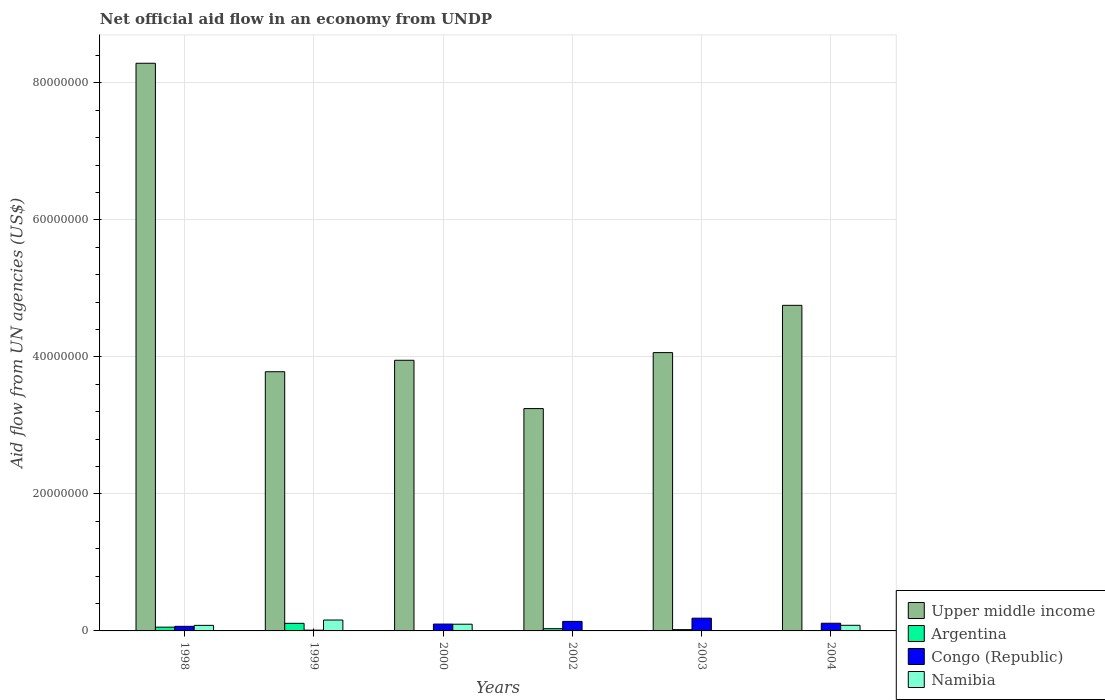Are the number of bars per tick equal to the number of legend labels?
Offer a very short reply. No. What is the net official aid flow in Namibia in 1999?
Make the answer very short. 1.59e+06. Across all years, what is the maximum net official aid flow in Congo (Republic)?
Your answer should be very brief. 1.86e+06. What is the total net official aid flow in Namibia in the graph?
Give a very brief answer. 4.26e+06. What is the difference between the net official aid flow in Upper middle income in 2002 and that in 2003?
Provide a succinct answer. -8.17e+06. What is the difference between the net official aid flow in Congo (Republic) in 2000 and the net official aid flow in Upper middle income in 2004?
Provide a succinct answer. -4.65e+07. What is the average net official aid flow in Argentina per year?
Your response must be concise. 3.63e+05. In the year 1999, what is the difference between the net official aid flow in Upper middle income and net official aid flow in Namibia?
Provide a short and direct response. 3.62e+07. What is the ratio of the net official aid flow in Argentina in 1999 to that in 2003?
Give a very brief answer. 5.84. What is the difference between the highest and the lowest net official aid flow in Namibia?
Offer a very short reply. 1.59e+06. Is the sum of the net official aid flow in Upper middle income in 1999 and 2004 greater than the maximum net official aid flow in Namibia across all years?
Keep it short and to the point. Yes. Is it the case that in every year, the sum of the net official aid flow in Upper middle income and net official aid flow in Argentina is greater than the net official aid flow in Namibia?
Ensure brevity in your answer.  Yes. How many bars are there?
Provide a succinct answer. 21. Are the values on the major ticks of Y-axis written in scientific E-notation?
Provide a short and direct response. No. Does the graph contain any zero values?
Give a very brief answer. Yes. How many legend labels are there?
Your answer should be very brief. 4. What is the title of the graph?
Your response must be concise. Net official aid flow in an economy from UNDP. Does "Jordan" appear as one of the legend labels in the graph?
Offer a terse response. No. What is the label or title of the Y-axis?
Provide a short and direct response. Aid flow from UN agencies (US$). What is the Aid flow from UN agencies (US$) of Upper middle income in 1998?
Make the answer very short. 8.28e+07. What is the Aid flow from UN agencies (US$) of Congo (Republic) in 1998?
Provide a succinct answer. 6.70e+05. What is the Aid flow from UN agencies (US$) in Namibia in 1998?
Your answer should be very brief. 8.10e+05. What is the Aid flow from UN agencies (US$) of Upper middle income in 1999?
Ensure brevity in your answer.  3.78e+07. What is the Aid flow from UN agencies (US$) in Argentina in 1999?
Your answer should be very brief. 1.11e+06. What is the Aid flow from UN agencies (US$) of Congo (Republic) in 1999?
Keep it short and to the point. 1.10e+05. What is the Aid flow from UN agencies (US$) in Namibia in 1999?
Make the answer very short. 1.59e+06. What is the Aid flow from UN agencies (US$) in Upper middle income in 2000?
Make the answer very short. 3.95e+07. What is the Aid flow from UN agencies (US$) of Argentina in 2000?
Provide a succinct answer. 0. What is the Aid flow from UN agencies (US$) of Namibia in 2000?
Offer a very short reply. 9.80e+05. What is the Aid flow from UN agencies (US$) in Upper middle income in 2002?
Ensure brevity in your answer.  3.24e+07. What is the Aid flow from UN agencies (US$) of Argentina in 2002?
Your answer should be compact. 3.30e+05. What is the Aid flow from UN agencies (US$) in Congo (Republic) in 2002?
Provide a succinct answer. 1.39e+06. What is the Aid flow from UN agencies (US$) in Namibia in 2002?
Provide a short and direct response. 0. What is the Aid flow from UN agencies (US$) in Upper middle income in 2003?
Keep it short and to the point. 4.06e+07. What is the Aid flow from UN agencies (US$) in Argentina in 2003?
Your answer should be very brief. 1.90e+05. What is the Aid flow from UN agencies (US$) of Congo (Republic) in 2003?
Offer a very short reply. 1.86e+06. What is the Aid flow from UN agencies (US$) of Namibia in 2003?
Give a very brief answer. 6.00e+04. What is the Aid flow from UN agencies (US$) in Upper middle income in 2004?
Make the answer very short. 4.75e+07. What is the Aid flow from UN agencies (US$) of Argentina in 2004?
Give a very brief answer. 0. What is the Aid flow from UN agencies (US$) of Congo (Republic) in 2004?
Make the answer very short. 1.12e+06. What is the Aid flow from UN agencies (US$) in Namibia in 2004?
Provide a short and direct response. 8.20e+05. Across all years, what is the maximum Aid flow from UN agencies (US$) of Upper middle income?
Your answer should be compact. 8.28e+07. Across all years, what is the maximum Aid flow from UN agencies (US$) of Argentina?
Offer a very short reply. 1.11e+06. Across all years, what is the maximum Aid flow from UN agencies (US$) in Congo (Republic)?
Offer a terse response. 1.86e+06. Across all years, what is the maximum Aid flow from UN agencies (US$) in Namibia?
Provide a short and direct response. 1.59e+06. Across all years, what is the minimum Aid flow from UN agencies (US$) of Upper middle income?
Your answer should be very brief. 3.24e+07. Across all years, what is the minimum Aid flow from UN agencies (US$) of Argentina?
Ensure brevity in your answer.  0. Across all years, what is the minimum Aid flow from UN agencies (US$) of Congo (Republic)?
Your answer should be very brief. 1.10e+05. Across all years, what is the minimum Aid flow from UN agencies (US$) in Namibia?
Offer a terse response. 0. What is the total Aid flow from UN agencies (US$) of Upper middle income in the graph?
Your response must be concise. 2.81e+08. What is the total Aid flow from UN agencies (US$) in Argentina in the graph?
Keep it short and to the point. 2.18e+06. What is the total Aid flow from UN agencies (US$) of Congo (Republic) in the graph?
Your response must be concise. 6.15e+06. What is the total Aid flow from UN agencies (US$) in Namibia in the graph?
Provide a succinct answer. 4.26e+06. What is the difference between the Aid flow from UN agencies (US$) in Upper middle income in 1998 and that in 1999?
Your answer should be compact. 4.50e+07. What is the difference between the Aid flow from UN agencies (US$) of Argentina in 1998 and that in 1999?
Offer a terse response. -5.60e+05. What is the difference between the Aid flow from UN agencies (US$) in Congo (Republic) in 1998 and that in 1999?
Give a very brief answer. 5.60e+05. What is the difference between the Aid flow from UN agencies (US$) in Namibia in 1998 and that in 1999?
Make the answer very short. -7.80e+05. What is the difference between the Aid flow from UN agencies (US$) in Upper middle income in 1998 and that in 2000?
Offer a very short reply. 4.34e+07. What is the difference between the Aid flow from UN agencies (US$) in Congo (Republic) in 1998 and that in 2000?
Give a very brief answer. -3.30e+05. What is the difference between the Aid flow from UN agencies (US$) of Namibia in 1998 and that in 2000?
Your answer should be very brief. -1.70e+05. What is the difference between the Aid flow from UN agencies (US$) in Upper middle income in 1998 and that in 2002?
Provide a succinct answer. 5.04e+07. What is the difference between the Aid flow from UN agencies (US$) in Congo (Republic) in 1998 and that in 2002?
Provide a short and direct response. -7.20e+05. What is the difference between the Aid flow from UN agencies (US$) in Upper middle income in 1998 and that in 2003?
Your answer should be compact. 4.22e+07. What is the difference between the Aid flow from UN agencies (US$) of Argentina in 1998 and that in 2003?
Ensure brevity in your answer.  3.60e+05. What is the difference between the Aid flow from UN agencies (US$) in Congo (Republic) in 1998 and that in 2003?
Provide a succinct answer. -1.19e+06. What is the difference between the Aid flow from UN agencies (US$) in Namibia in 1998 and that in 2003?
Provide a succinct answer. 7.50e+05. What is the difference between the Aid flow from UN agencies (US$) in Upper middle income in 1998 and that in 2004?
Your answer should be compact. 3.53e+07. What is the difference between the Aid flow from UN agencies (US$) in Congo (Republic) in 1998 and that in 2004?
Your answer should be very brief. -4.50e+05. What is the difference between the Aid flow from UN agencies (US$) in Upper middle income in 1999 and that in 2000?
Provide a succinct answer. -1.67e+06. What is the difference between the Aid flow from UN agencies (US$) of Congo (Republic) in 1999 and that in 2000?
Give a very brief answer. -8.90e+05. What is the difference between the Aid flow from UN agencies (US$) in Namibia in 1999 and that in 2000?
Make the answer very short. 6.10e+05. What is the difference between the Aid flow from UN agencies (US$) of Upper middle income in 1999 and that in 2002?
Your answer should be compact. 5.38e+06. What is the difference between the Aid flow from UN agencies (US$) in Argentina in 1999 and that in 2002?
Your answer should be compact. 7.80e+05. What is the difference between the Aid flow from UN agencies (US$) in Congo (Republic) in 1999 and that in 2002?
Offer a very short reply. -1.28e+06. What is the difference between the Aid flow from UN agencies (US$) in Upper middle income in 1999 and that in 2003?
Give a very brief answer. -2.79e+06. What is the difference between the Aid flow from UN agencies (US$) of Argentina in 1999 and that in 2003?
Make the answer very short. 9.20e+05. What is the difference between the Aid flow from UN agencies (US$) in Congo (Republic) in 1999 and that in 2003?
Offer a very short reply. -1.75e+06. What is the difference between the Aid flow from UN agencies (US$) in Namibia in 1999 and that in 2003?
Keep it short and to the point. 1.53e+06. What is the difference between the Aid flow from UN agencies (US$) of Upper middle income in 1999 and that in 2004?
Offer a very short reply. -9.69e+06. What is the difference between the Aid flow from UN agencies (US$) in Congo (Republic) in 1999 and that in 2004?
Give a very brief answer. -1.01e+06. What is the difference between the Aid flow from UN agencies (US$) of Namibia in 1999 and that in 2004?
Ensure brevity in your answer.  7.70e+05. What is the difference between the Aid flow from UN agencies (US$) in Upper middle income in 2000 and that in 2002?
Make the answer very short. 7.05e+06. What is the difference between the Aid flow from UN agencies (US$) in Congo (Republic) in 2000 and that in 2002?
Provide a succinct answer. -3.90e+05. What is the difference between the Aid flow from UN agencies (US$) of Upper middle income in 2000 and that in 2003?
Keep it short and to the point. -1.12e+06. What is the difference between the Aid flow from UN agencies (US$) in Congo (Republic) in 2000 and that in 2003?
Offer a very short reply. -8.60e+05. What is the difference between the Aid flow from UN agencies (US$) in Namibia in 2000 and that in 2003?
Offer a very short reply. 9.20e+05. What is the difference between the Aid flow from UN agencies (US$) in Upper middle income in 2000 and that in 2004?
Your answer should be very brief. -8.02e+06. What is the difference between the Aid flow from UN agencies (US$) of Upper middle income in 2002 and that in 2003?
Your answer should be compact. -8.17e+06. What is the difference between the Aid flow from UN agencies (US$) of Argentina in 2002 and that in 2003?
Provide a succinct answer. 1.40e+05. What is the difference between the Aid flow from UN agencies (US$) in Congo (Republic) in 2002 and that in 2003?
Ensure brevity in your answer.  -4.70e+05. What is the difference between the Aid flow from UN agencies (US$) in Upper middle income in 2002 and that in 2004?
Your answer should be very brief. -1.51e+07. What is the difference between the Aid flow from UN agencies (US$) in Upper middle income in 2003 and that in 2004?
Your response must be concise. -6.90e+06. What is the difference between the Aid flow from UN agencies (US$) in Congo (Republic) in 2003 and that in 2004?
Your response must be concise. 7.40e+05. What is the difference between the Aid flow from UN agencies (US$) of Namibia in 2003 and that in 2004?
Offer a terse response. -7.60e+05. What is the difference between the Aid flow from UN agencies (US$) in Upper middle income in 1998 and the Aid flow from UN agencies (US$) in Argentina in 1999?
Make the answer very short. 8.17e+07. What is the difference between the Aid flow from UN agencies (US$) in Upper middle income in 1998 and the Aid flow from UN agencies (US$) in Congo (Republic) in 1999?
Your response must be concise. 8.27e+07. What is the difference between the Aid flow from UN agencies (US$) in Upper middle income in 1998 and the Aid flow from UN agencies (US$) in Namibia in 1999?
Ensure brevity in your answer.  8.13e+07. What is the difference between the Aid flow from UN agencies (US$) in Argentina in 1998 and the Aid flow from UN agencies (US$) in Namibia in 1999?
Ensure brevity in your answer.  -1.04e+06. What is the difference between the Aid flow from UN agencies (US$) of Congo (Republic) in 1998 and the Aid flow from UN agencies (US$) of Namibia in 1999?
Your answer should be compact. -9.20e+05. What is the difference between the Aid flow from UN agencies (US$) in Upper middle income in 1998 and the Aid flow from UN agencies (US$) in Congo (Republic) in 2000?
Provide a short and direct response. 8.18e+07. What is the difference between the Aid flow from UN agencies (US$) in Upper middle income in 1998 and the Aid flow from UN agencies (US$) in Namibia in 2000?
Make the answer very short. 8.19e+07. What is the difference between the Aid flow from UN agencies (US$) in Argentina in 1998 and the Aid flow from UN agencies (US$) in Congo (Republic) in 2000?
Your answer should be compact. -4.50e+05. What is the difference between the Aid flow from UN agencies (US$) of Argentina in 1998 and the Aid flow from UN agencies (US$) of Namibia in 2000?
Provide a short and direct response. -4.30e+05. What is the difference between the Aid flow from UN agencies (US$) of Congo (Republic) in 1998 and the Aid flow from UN agencies (US$) of Namibia in 2000?
Make the answer very short. -3.10e+05. What is the difference between the Aid flow from UN agencies (US$) in Upper middle income in 1998 and the Aid flow from UN agencies (US$) in Argentina in 2002?
Make the answer very short. 8.25e+07. What is the difference between the Aid flow from UN agencies (US$) of Upper middle income in 1998 and the Aid flow from UN agencies (US$) of Congo (Republic) in 2002?
Provide a short and direct response. 8.15e+07. What is the difference between the Aid flow from UN agencies (US$) in Argentina in 1998 and the Aid flow from UN agencies (US$) in Congo (Republic) in 2002?
Provide a short and direct response. -8.40e+05. What is the difference between the Aid flow from UN agencies (US$) in Upper middle income in 1998 and the Aid flow from UN agencies (US$) in Argentina in 2003?
Make the answer very short. 8.27e+07. What is the difference between the Aid flow from UN agencies (US$) of Upper middle income in 1998 and the Aid flow from UN agencies (US$) of Congo (Republic) in 2003?
Offer a terse response. 8.10e+07. What is the difference between the Aid flow from UN agencies (US$) of Upper middle income in 1998 and the Aid flow from UN agencies (US$) of Namibia in 2003?
Offer a very short reply. 8.28e+07. What is the difference between the Aid flow from UN agencies (US$) in Argentina in 1998 and the Aid flow from UN agencies (US$) in Congo (Republic) in 2003?
Offer a very short reply. -1.31e+06. What is the difference between the Aid flow from UN agencies (US$) in Argentina in 1998 and the Aid flow from UN agencies (US$) in Namibia in 2003?
Your answer should be very brief. 4.90e+05. What is the difference between the Aid flow from UN agencies (US$) in Upper middle income in 1998 and the Aid flow from UN agencies (US$) in Congo (Republic) in 2004?
Your answer should be compact. 8.17e+07. What is the difference between the Aid flow from UN agencies (US$) in Upper middle income in 1998 and the Aid flow from UN agencies (US$) in Namibia in 2004?
Your response must be concise. 8.20e+07. What is the difference between the Aid flow from UN agencies (US$) in Argentina in 1998 and the Aid flow from UN agencies (US$) in Congo (Republic) in 2004?
Your answer should be very brief. -5.70e+05. What is the difference between the Aid flow from UN agencies (US$) of Congo (Republic) in 1998 and the Aid flow from UN agencies (US$) of Namibia in 2004?
Your answer should be very brief. -1.50e+05. What is the difference between the Aid flow from UN agencies (US$) in Upper middle income in 1999 and the Aid flow from UN agencies (US$) in Congo (Republic) in 2000?
Your answer should be compact. 3.68e+07. What is the difference between the Aid flow from UN agencies (US$) in Upper middle income in 1999 and the Aid flow from UN agencies (US$) in Namibia in 2000?
Make the answer very short. 3.68e+07. What is the difference between the Aid flow from UN agencies (US$) of Argentina in 1999 and the Aid flow from UN agencies (US$) of Congo (Republic) in 2000?
Offer a very short reply. 1.10e+05. What is the difference between the Aid flow from UN agencies (US$) of Argentina in 1999 and the Aid flow from UN agencies (US$) of Namibia in 2000?
Provide a succinct answer. 1.30e+05. What is the difference between the Aid flow from UN agencies (US$) of Congo (Republic) in 1999 and the Aid flow from UN agencies (US$) of Namibia in 2000?
Your response must be concise. -8.70e+05. What is the difference between the Aid flow from UN agencies (US$) of Upper middle income in 1999 and the Aid flow from UN agencies (US$) of Argentina in 2002?
Your response must be concise. 3.75e+07. What is the difference between the Aid flow from UN agencies (US$) of Upper middle income in 1999 and the Aid flow from UN agencies (US$) of Congo (Republic) in 2002?
Make the answer very short. 3.64e+07. What is the difference between the Aid flow from UN agencies (US$) of Argentina in 1999 and the Aid flow from UN agencies (US$) of Congo (Republic) in 2002?
Offer a terse response. -2.80e+05. What is the difference between the Aid flow from UN agencies (US$) of Upper middle income in 1999 and the Aid flow from UN agencies (US$) of Argentina in 2003?
Ensure brevity in your answer.  3.76e+07. What is the difference between the Aid flow from UN agencies (US$) of Upper middle income in 1999 and the Aid flow from UN agencies (US$) of Congo (Republic) in 2003?
Make the answer very short. 3.60e+07. What is the difference between the Aid flow from UN agencies (US$) of Upper middle income in 1999 and the Aid flow from UN agencies (US$) of Namibia in 2003?
Ensure brevity in your answer.  3.78e+07. What is the difference between the Aid flow from UN agencies (US$) of Argentina in 1999 and the Aid flow from UN agencies (US$) of Congo (Republic) in 2003?
Provide a short and direct response. -7.50e+05. What is the difference between the Aid flow from UN agencies (US$) in Argentina in 1999 and the Aid flow from UN agencies (US$) in Namibia in 2003?
Offer a very short reply. 1.05e+06. What is the difference between the Aid flow from UN agencies (US$) of Upper middle income in 1999 and the Aid flow from UN agencies (US$) of Congo (Republic) in 2004?
Offer a terse response. 3.67e+07. What is the difference between the Aid flow from UN agencies (US$) of Upper middle income in 1999 and the Aid flow from UN agencies (US$) of Namibia in 2004?
Keep it short and to the point. 3.70e+07. What is the difference between the Aid flow from UN agencies (US$) of Argentina in 1999 and the Aid flow from UN agencies (US$) of Congo (Republic) in 2004?
Give a very brief answer. -10000. What is the difference between the Aid flow from UN agencies (US$) in Congo (Republic) in 1999 and the Aid flow from UN agencies (US$) in Namibia in 2004?
Keep it short and to the point. -7.10e+05. What is the difference between the Aid flow from UN agencies (US$) of Upper middle income in 2000 and the Aid flow from UN agencies (US$) of Argentina in 2002?
Ensure brevity in your answer.  3.92e+07. What is the difference between the Aid flow from UN agencies (US$) of Upper middle income in 2000 and the Aid flow from UN agencies (US$) of Congo (Republic) in 2002?
Give a very brief answer. 3.81e+07. What is the difference between the Aid flow from UN agencies (US$) in Upper middle income in 2000 and the Aid flow from UN agencies (US$) in Argentina in 2003?
Offer a terse response. 3.93e+07. What is the difference between the Aid flow from UN agencies (US$) of Upper middle income in 2000 and the Aid flow from UN agencies (US$) of Congo (Republic) in 2003?
Offer a terse response. 3.76e+07. What is the difference between the Aid flow from UN agencies (US$) in Upper middle income in 2000 and the Aid flow from UN agencies (US$) in Namibia in 2003?
Give a very brief answer. 3.94e+07. What is the difference between the Aid flow from UN agencies (US$) in Congo (Republic) in 2000 and the Aid flow from UN agencies (US$) in Namibia in 2003?
Your answer should be compact. 9.40e+05. What is the difference between the Aid flow from UN agencies (US$) in Upper middle income in 2000 and the Aid flow from UN agencies (US$) in Congo (Republic) in 2004?
Provide a short and direct response. 3.84e+07. What is the difference between the Aid flow from UN agencies (US$) in Upper middle income in 2000 and the Aid flow from UN agencies (US$) in Namibia in 2004?
Offer a terse response. 3.87e+07. What is the difference between the Aid flow from UN agencies (US$) of Congo (Republic) in 2000 and the Aid flow from UN agencies (US$) of Namibia in 2004?
Your response must be concise. 1.80e+05. What is the difference between the Aid flow from UN agencies (US$) in Upper middle income in 2002 and the Aid flow from UN agencies (US$) in Argentina in 2003?
Offer a terse response. 3.23e+07. What is the difference between the Aid flow from UN agencies (US$) in Upper middle income in 2002 and the Aid flow from UN agencies (US$) in Congo (Republic) in 2003?
Your answer should be compact. 3.06e+07. What is the difference between the Aid flow from UN agencies (US$) of Upper middle income in 2002 and the Aid flow from UN agencies (US$) of Namibia in 2003?
Provide a succinct answer. 3.24e+07. What is the difference between the Aid flow from UN agencies (US$) in Argentina in 2002 and the Aid flow from UN agencies (US$) in Congo (Republic) in 2003?
Give a very brief answer. -1.53e+06. What is the difference between the Aid flow from UN agencies (US$) of Congo (Republic) in 2002 and the Aid flow from UN agencies (US$) of Namibia in 2003?
Make the answer very short. 1.33e+06. What is the difference between the Aid flow from UN agencies (US$) in Upper middle income in 2002 and the Aid flow from UN agencies (US$) in Congo (Republic) in 2004?
Ensure brevity in your answer.  3.13e+07. What is the difference between the Aid flow from UN agencies (US$) of Upper middle income in 2002 and the Aid flow from UN agencies (US$) of Namibia in 2004?
Make the answer very short. 3.16e+07. What is the difference between the Aid flow from UN agencies (US$) of Argentina in 2002 and the Aid flow from UN agencies (US$) of Congo (Republic) in 2004?
Your answer should be very brief. -7.90e+05. What is the difference between the Aid flow from UN agencies (US$) of Argentina in 2002 and the Aid flow from UN agencies (US$) of Namibia in 2004?
Offer a very short reply. -4.90e+05. What is the difference between the Aid flow from UN agencies (US$) of Congo (Republic) in 2002 and the Aid flow from UN agencies (US$) of Namibia in 2004?
Your answer should be compact. 5.70e+05. What is the difference between the Aid flow from UN agencies (US$) in Upper middle income in 2003 and the Aid flow from UN agencies (US$) in Congo (Republic) in 2004?
Your answer should be very brief. 3.95e+07. What is the difference between the Aid flow from UN agencies (US$) in Upper middle income in 2003 and the Aid flow from UN agencies (US$) in Namibia in 2004?
Provide a succinct answer. 3.98e+07. What is the difference between the Aid flow from UN agencies (US$) of Argentina in 2003 and the Aid flow from UN agencies (US$) of Congo (Republic) in 2004?
Your response must be concise. -9.30e+05. What is the difference between the Aid flow from UN agencies (US$) of Argentina in 2003 and the Aid flow from UN agencies (US$) of Namibia in 2004?
Provide a short and direct response. -6.30e+05. What is the difference between the Aid flow from UN agencies (US$) of Congo (Republic) in 2003 and the Aid flow from UN agencies (US$) of Namibia in 2004?
Ensure brevity in your answer.  1.04e+06. What is the average Aid flow from UN agencies (US$) in Upper middle income per year?
Provide a short and direct response. 4.68e+07. What is the average Aid flow from UN agencies (US$) in Argentina per year?
Ensure brevity in your answer.  3.63e+05. What is the average Aid flow from UN agencies (US$) of Congo (Republic) per year?
Ensure brevity in your answer.  1.02e+06. What is the average Aid flow from UN agencies (US$) of Namibia per year?
Provide a short and direct response. 7.10e+05. In the year 1998, what is the difference between the Aid flow from UN agencies (US$) of Upper middle income and Aid flow from UN agencies (US$) of Argentina?
Offer a very short reply. 8.23e+07. In the year 1998, what is the difference between the Aid flow from UN agencies (US$) of Upper middle income and Aid flow from UN agencies (US$) of Congo (Republic)?
Ensure brevity in your answer.  8.22e+07. In the year 1998, what is the difference between the Aid flow from UN agencies (US$) of Upper middle income and Aid flow from UN agencies (US$) of Namibia?
Give a very brief answer. 8.20e+07. In the year 1998, what is the difference between the Aid flow from UN agencies (US$) of Argentina and Aid flow from UN agencies (US$) of Congo (Republic)?
Offer a very short reply. -1.20e+05. In the year 1998, what is the difference between the Aid flow from UN agencies (US$) in Argentina and Aid flow from UN agencies (US$) in Namibia?
Your answer should be very brief. -2.60e+05. In the year 1999, what is the difference between the Aid flow from UN agencies (US$) of Upper middle income and Aid flow from UN agencies (US$) of Argentina?
Provide a succinct answer. 3.67e+07. In the year 1999, what is the difference between the Aid flow from UN agencies (US$) of Upper middle income and Aid flow from UN agencies (US$) of Congo (Republic)?
Ensure brevity in your answer.  3.77e+07. In the year 1999, what is the difference between the Aid flow from UN agencies (US$) of Upper middle income and Aid flow from UN agencies (US$) of Namibia?
Make the answer very short. 3.62e+07. In the year 1999, what is the difference between the Aid flow from UN agencies (US$) of Argentina and Aid flow from UN agencies (US$) of Congo (Republic)?
Provide a succinct answer. 1.00e+06. In the year 1999, what is the difference between the Aid flow from UN agencies (US$) in Argentina and Aid flow from UN agencies (US$) in Namibia?
Offer a very short reply. -4.80e+05. In the year 1999, what is the difference between the Aid flow from UN agencies (US$) in Congo (Republic) and Aid flow from UN agencies (US$) in Namibia?
Your answer should be compact. -1.48e+06. In the year 2000, what is the difference between the Aid flow from UN agencies (US$) of Upper middle income and Aid flow from UN agencies (US$) of Congo (Republic)?
Give a very brief answer. 3.85e+07. In the year 2000, what is the difference between the Aid flow from UN agencies (US$) in Upper middle income and Aid flow from UN agencies (US$) in Namibia?
Provide a succinct answer. 3.85e+07. In the year 2000, what is the difference between the Aid flow from UN agencies (US$) in Congo (Republic) and Aid flow from UN agencies (US$) in Namibia?
Ensure brevity in your answer.  2.00e+04. In the year 2002, what is the difference between the Aid flow from UN agencies (US$) of Upper middle income and Aid flow from UN agencies (US$) of Argentina?
Provide a succinct answer. 3.21e+07. In the year 2002, what is the difference between the Aid flow from UN agencies (US$) of Upper middle income and Aid flow from UN agencies (US$) of Congo (Republic)?
Ensure brevity in your answer.  3.11e+07. In the year 2002, what is the difference between the Aid flow from UN agencies (US$) in Argentina and Aid flow from UN agencies (US$) in Congo (Republic)?
Make the answer very short. -1.06e+06. In the year 2003, what is the difference between the Aid flow from UN agencies (US$) in Upper middle income and Aid flow from UN agencies (US$) in Argentina?
Provide a short and direct response. 4.04e+07. In the year 2003, what is the difference between the Aid flow from UN agencies (US$) in Upper middle income and Aid flow from UN agencies (US$) in Congo (Republic)?
Offer a very short reply. 3.88e+07. In the year 2003, what is the difference between the Aid flow from UN agencies (US$) in Upper middle income and Aid flow from UN agencies (US$) in Namibia?
Offer a very short reply. 4.06e+07. In the year 2003, what is the difference between the Aid flow from UN agencies (US$) in Argentina and Aid flow from UN agencies (US$) in Congo (Republic)?
Offer a terse response. -1.67e+06. In the year 2003, what is the difference between the Aid flow from UN agencies (US$) of Congo (Republic) and Aid flow from UN agencies (US$) of Namibia?
Offer a very short reply. 1.80e+06. In the year 2004, what is the difference between the Aid flow from UN agencies (US$) of Upper middle income and Aid flow from UN agencies (US$) of Congo (Republic)?
Your answer should be compact. 4.64e+07. In the year 2004, what is the difference between the Aid flow from UN agencies (US$) of Upper middle income and Aid flow from UN agencies (US$) of Namibia?
Keep it short and to the point. 4.67e+07. What is the ratio of the Aid flow from UN agencies (US$) of Upper middle income in 1998 to that in 1999?
Offer a terse response. 2.19. What is the ratio of the Aid flow from UN agencies (US$) in Argentina in 1998 to that in 1999?
Provide a succinct answer. 0.5. What is the ratio of the Aid flow from UN agencies (US$) in Congo (Republic) in 1998 to that in 1999?
Offer a very short reply. 6.09. What is the ratio of the Aid flow from UN agencies (US$) of Namibia in 1998 to that in 1999?
Offer a terse response. 0.51. What is the ratio of the Aid flow from UN agencies (US$) of Upper middle income in 1998 to that in 2000?
Offer a very short reply. 2.1. What is the ratio of the Aid flow from UN agencies (US$) in Congo (Republic) in 1998 to that in 2000?
Your answer should be very brief. 0.67. What is the ratio of the Aid flow from UN agencies (US$) in Namibia in 1998 to that in 2000?
Provide a short and direct response. 0.83. What is the ratio of the Aid flow from UN agencies (US$) in Upper middle income in 1998 to that in 2002?
Keep it short and to the point. 2.55. What is the ratio of the Aid flow from UN agencies (US$) in Congo (Republic) in 1998 to that in 2002?
Your answer should be compact. 0.48. What is the ratio of the Aid flow from UN agencies (US$) of Upper middle income in 1998 to that in 2003?
Give a very brief answer. 2.04. What is the ratio of the Aid flow from UN agencies (US$) of Argentina in 1998 to that in 2003?
Make the answer very short. 2.89. What is the ratio of the Aid flow from UN agencies (US$) of Congo (Republic) in 1998 to that in 2003?
Your answer should be very brief. 0.36. What is the ratio of the Aid flow from UN agencies (US$) of Namibia in 1998 to that in 2003?
Keep it short and to the point. 13.5. What is the ratio of the Aid flow from UN agencies (US$) in Upper middle income in 1998 to that in 2004?
Your answer should be compact. 1.74. What is the ratio of the Aid flow from UN agencies (US$) in Congo (Republic) in 1998 to that in 2004?
Make the answer very short. 0.6. What is the ratio of the Aid flow from UN agencies (US$) in Namibia in 1998 to that in 2004?
Make the answer very short. 0.99. What is the ratio of the Aid flow from UN agencies (US$) in Upper middle income in 1999 to that in 2000?
Provide a short and direct response. 0.96. What is the ratio of the Aid flow from UN agencies (US$) in Congo (Republic) in 1999 to that in 2000?
Ensure brevity in your answer.  0.11. What is the ratio of the Aid flow from UN agencies (US$) of Namibia in 1999 to that in 2000?
Your response must be concise. 1.62. What is the ratio of the Aid flow from UN agencies (US$) of Upper middle income in 1999 to that in 2002?
Give a very brief answer. 1.17. What is the ratio of the Aid flow from UN agencies (US$) of Argentina in 1999 to that in 2002?
Your answer should be very brief. 3.36. What is the ratio of the Aid flow from UN agencies (US$) in Congo (Republic) in 1999 to that in 2002?
Make the answer very short. 0.08. What is the ratio of the Aid flow from UN agencies (US$) of Upper middle income in 1999 to that in 2003?
Offer a terse response. 0.93. What is the ratio of the Aid flow from UN agencies (US$) in Argentina in 1999 to that in 2003?
Keep it short and to the point. 5.84. What is the ratio of the Aid flow from UN agencies (US$) in Congo (Republic) in 1999 to that in 2003?
Provide a succinct answer. 0.06. What is the ratio of the Aid flow from UN agencies (US$) in Upper middle income in 1999 to that in 2004?
Offer a very short reply. 0.8. What is the ratio of the Aid flow from UN agencies (US$) of Congo (Republic) in 1999 to that in 2004?
Your answer should be compact. 0.1. What is the ratio of the Aid flow from UN agencies (US$) in Namibia in 1999 to that in 2004?
Give a very brief answer. 1.94. What is the ratio of the Aid flow from UN agencies (US$) in Upper middle income in 2000 to that in 2002?
Give a very brief answer. 1.22. What is the ratio of the Aid flow from UN agencies (US$) of Congo (Republic) in 2000 to that in 2002?
Your answer should be very brief. 0.72. What is the ratio of the Aid flow from UN agencies (US$) of Upper middle income in 2000 to that in 2003?
Provide a succinct answer. 0.97. What is the ratio of the Aid flow from UN agencies (US$) of Congo (Republic) in 2000 to that in 2003?
Keep it short and to the point. 0.54. What is the ratio of the Aid flow from UN agencies (US$) of Namibia in 2000 to that in 2003?
Offer a terse response. 16.33. What is the ratio of the Aid flow from UN agencies (US$) of Upper middle income in 2000 to that in 2004?
Provide a succinct answer. 0.83. What is the ratio of the Aid flow from UN agencies (US$) of Congo (Republic) in 2000 to that in 2004?
Your answer should be compact. 0.89. What is the ratio of the Aid flow from UN agencies (US$) in Namibia in 2000 to that in 2004?
Keep it short and to the point. 1.2. What is the ratio of the Aid flow from UN agencies (US$) of Upper middle income in 2002 to that in 2003?
Offer a very short reply. 0.8. What is the ratio of the Aid flow from UN agencies (US$) in Argentina in 2002 to that in 2003?
Keep it short and to the point. 1.74. What is the ratio of the Aid flow from UN agencies (US$) in Congo (Republic) in 2002 to that in 2003?
Offer a terse response. 0.75. What is the ratio of the Aid flow from UN agencies (US$) of Upper middle income in 2002 to that in 2004?
Ensure brevity in your answer.  0.68. What is the ratio of the Aid flow from UN agencies (US$) of Congo (Republic) in 2002 to that in 2004?
Provide a short and direct response. 1.24. What is the ratio of the Aid flow from UN agencies (US$) in Upper middle income in 2003 to that in 2004?
Your answer should be very brief. 0.85. What is the ratio of the Aid flow from UN agencies (US$) in Congo (Republic) in 2003 to that in 2004?
Make the answer very short. 1.66. What is the ratio of the Aid flow from UN agencies (US$) in Namibia in 2003 to that in 2004?
Offer a very short reply. 0.07. What is the difference between the highest and the second highest Aid flow from UN agencies (US$) in Upper middle income?
Offer a very short reply. 3.53e+07. What is the difference between the highest and the second highest Aid flow from UN agencies (US$) of Argentina?
Give a very brief answer. 5.60e+05. What is the difference between the highest and the second highest Aid flow from UN agencies (US$) in Congo (Republic)?
Ensure brevity in your answer.  4.70e+05. What is the difference between the highest and the lowest Aid flow from UN agencies (US$) in Upper middle income?
Your answer should be compact. 5.04e+07. What is the difference between the highest and the lowest Aid flow from UN agencies (US$) of Argentina?
Provide a succinct answer. 1.11e+06. What is the difference between the highest and the lowest Aid flow from UN agencies (US$) in Congo (Republic)?
Your answer should be compact. 1.75e+06. What is the difference between the highest and the lowest Aid flow from UN agencies (US$) in Namibia?
Offer a terse response. 1.59e+06. 